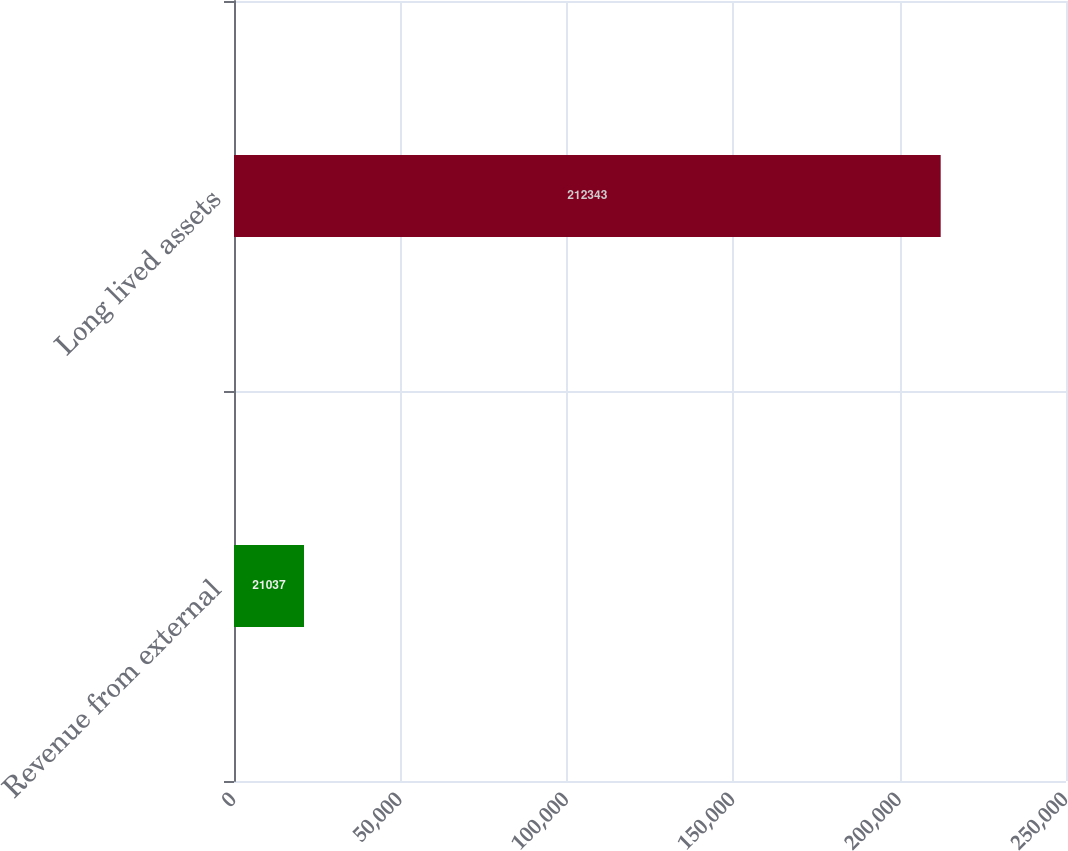Convert chart to OTSL. <chart><loc_0><loc_0><loc_500><loc_500><bar_chart><fcel>Revenue from external<fcel>Long lived assets<nl><fcel>21037<fcel>212343<nl></chart> 